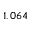<formula> <loc_0><loc_0><loc_500><loc_500>1 , 0 6 4</formula> 